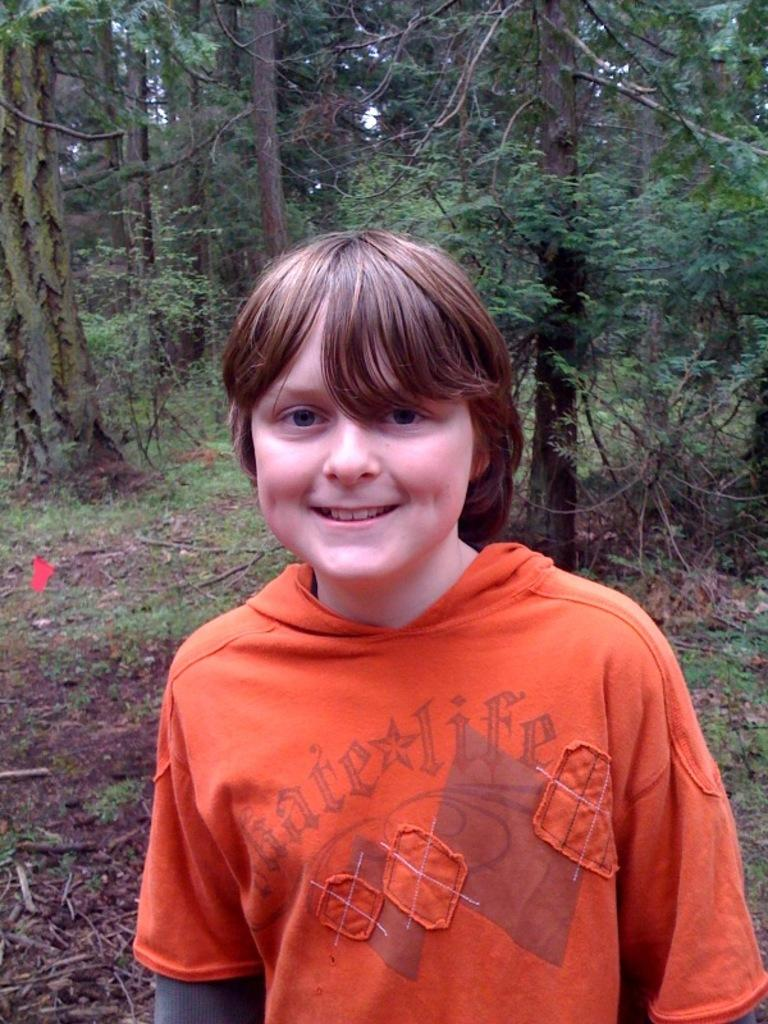Who is the main subject in the image? There is a boy in the image. What is the boy wearing? The boy is wearing an orange jacket. What can be seen in the background of the image? There are trees in the background of the image. How many pencils are visible in the image? There are no pencils visible in the image. What type of cats can be seen playing in the image? There are no cats present in the image. 